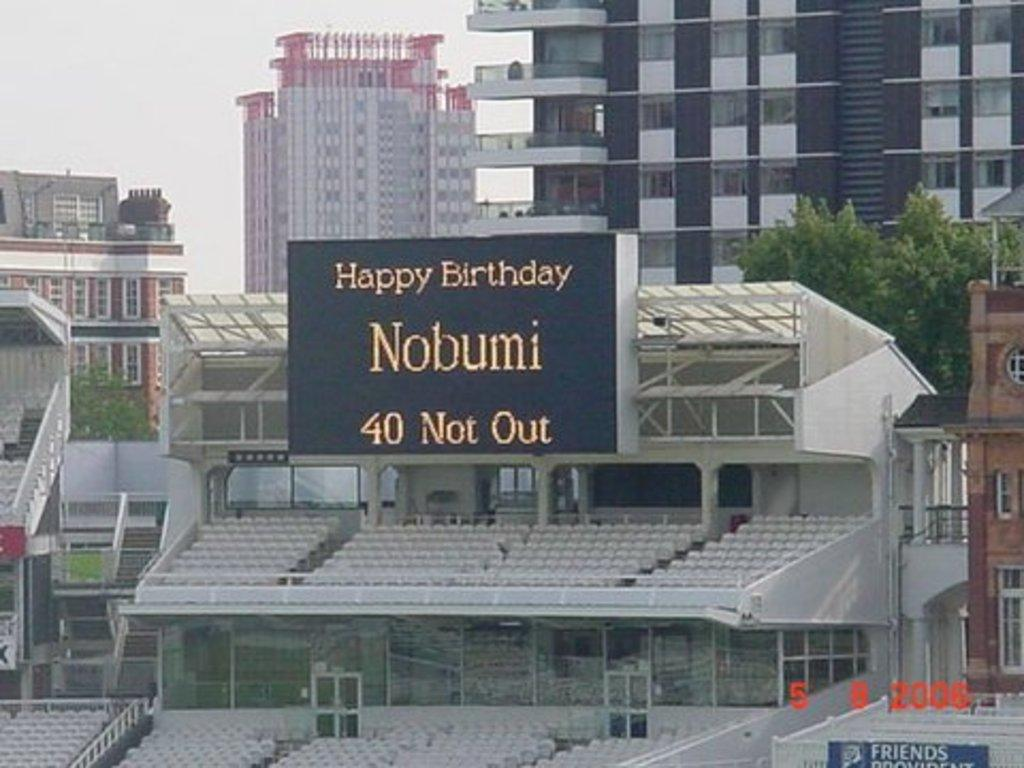<image>
Offer a succinct explanation of the picture presented. a large electronic sign that reads happy birthday nobumi. 